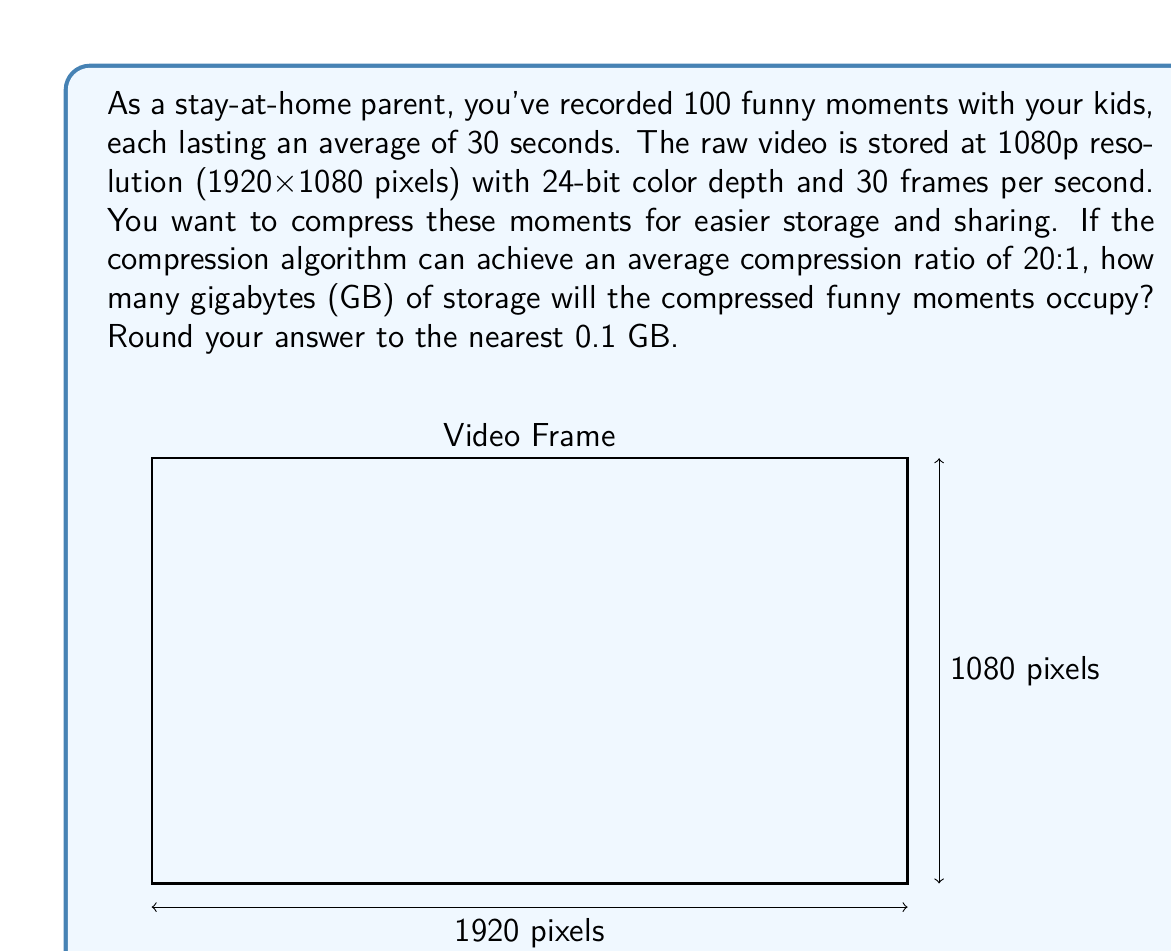Give your solution to this math problem. Let's break this down step-by-step:

1) First, calculate the size of one frame:
   $1920 \times 1080 \text{ pixels} \times 24 \text{ bits/pixel} = 49,766,400 \text{ bits}$

2) Convert to bytes:
   $49,766,400 \text{ bits} \div 8 \text{ bits/byte} = 6,220,800 \text{ bytes}$

3) Calculate frames per funny moment:
   $30 \text{ seconds} \times 30 \text{ frames/second} = 900 \text{ frames}$

4) Calculate size of one funny moment:
   $6,220,800 \text{ bytes/frame} \times 900 \text{ frames} = 5,598,720,000 \text{ bytes}$

5) Calculate total size for 100 funny moments:
   $5,598,720,000 \text{ bytes} \times 100 = 559,872,000,000 \text{ bytes}$

6) Convert to gigabytes:
   $559,872,000,000 \text{ bytes} \div (1024^3 \text{ bytes/GB}) \approx 521.4 \text{ GB}$

7) Apply compression ratio of 20:1:
   $521.4 \text{ GB} \div 20 \approx 26.07 \text{ GB}$

8) Rounding to the nearest 0.1 GB:
   $26.1 \text{ GB}$
Answer: 26.1 GB 